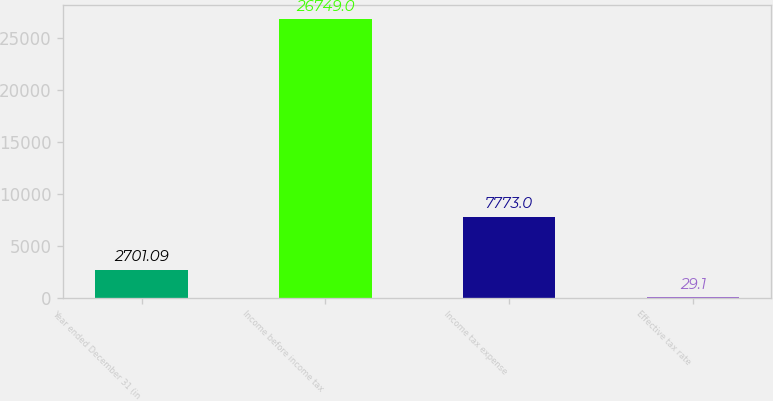Convert chart to OTSL. <chart><loc_0><loc_0><loc_500><loc_500><bar_chart><fcel>Year ended December 31 (in<fcel>Income before income tax<fcel>Income tax expense<fcel>Effective tax rate<nl><fcel>2701.09<fcel>26749<fcel>7773<fcel>29.1<nl></chart> 